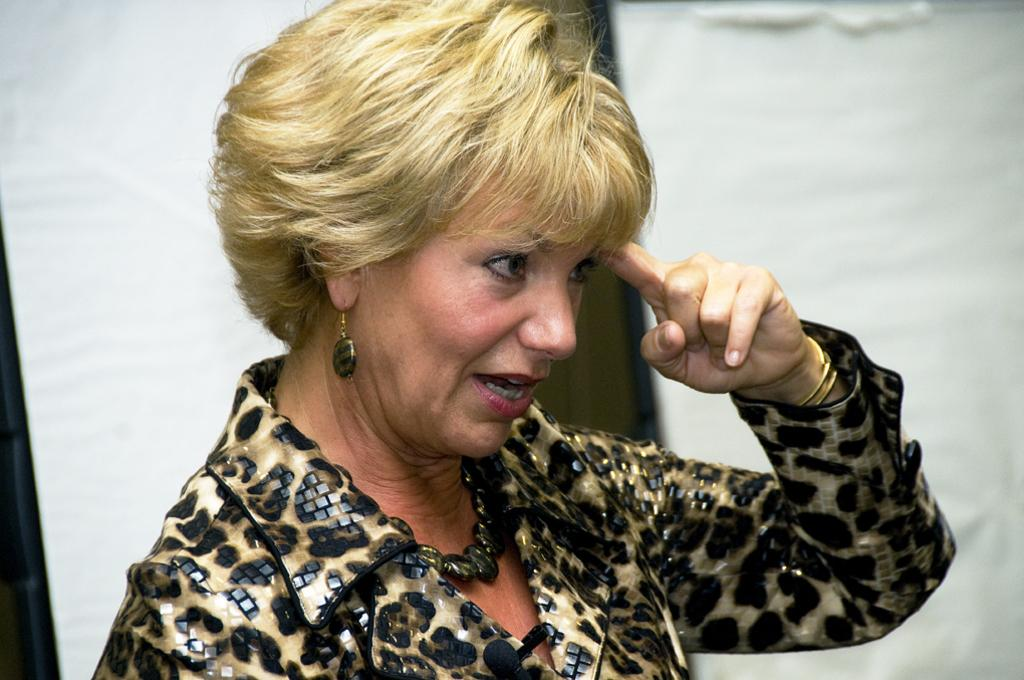Who is the main subject in the image? There is a woman in the image. What is the woman doing in the image? The woman is speaking. Can you describe the woman's attire in the image? The woman is wearing a designer dress. How is the background of the image depicted? The background of the woman is blurred. What type of cushion is the woman sitting on in the image? There is no cushion present in the image, and the woman is not sitting down. 